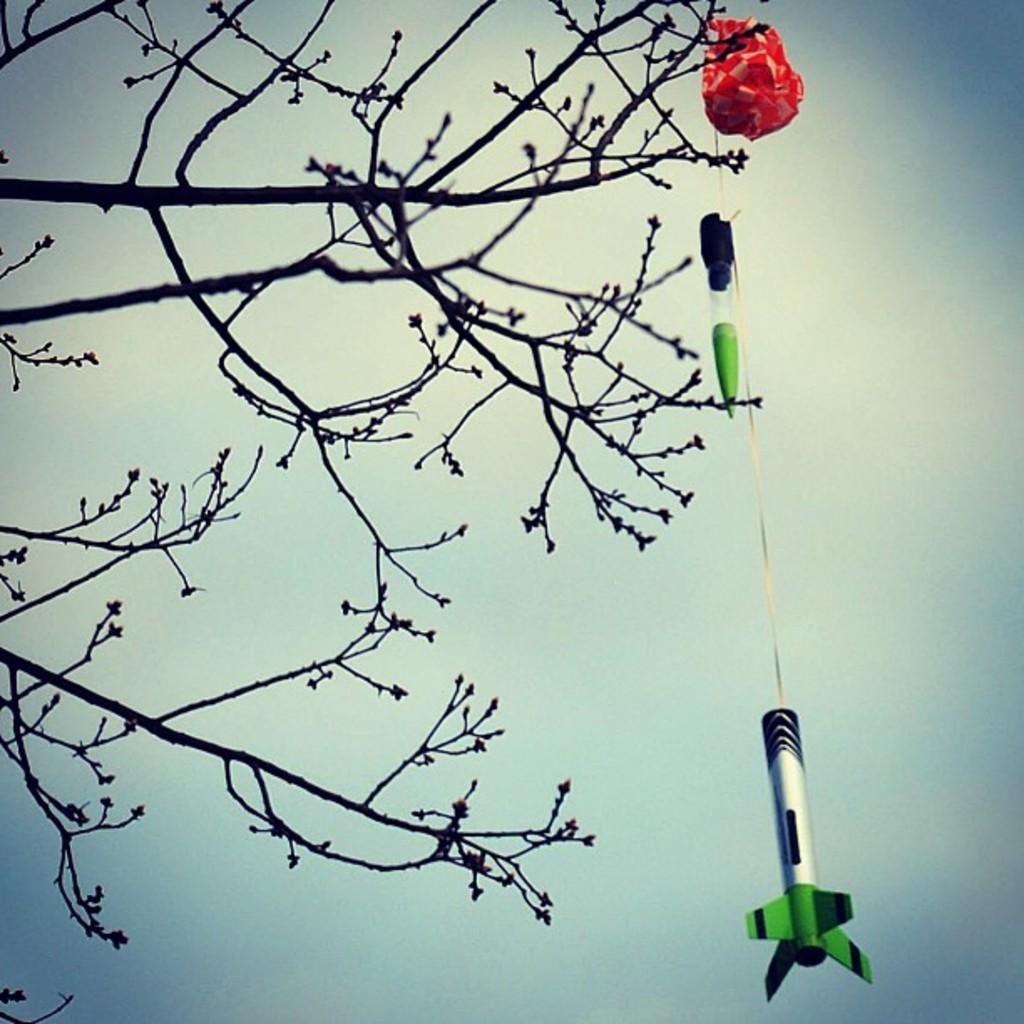Can you describe this image briefly? In this image we can see stem of a tree and one red green and black color thing is attached to the tree. 